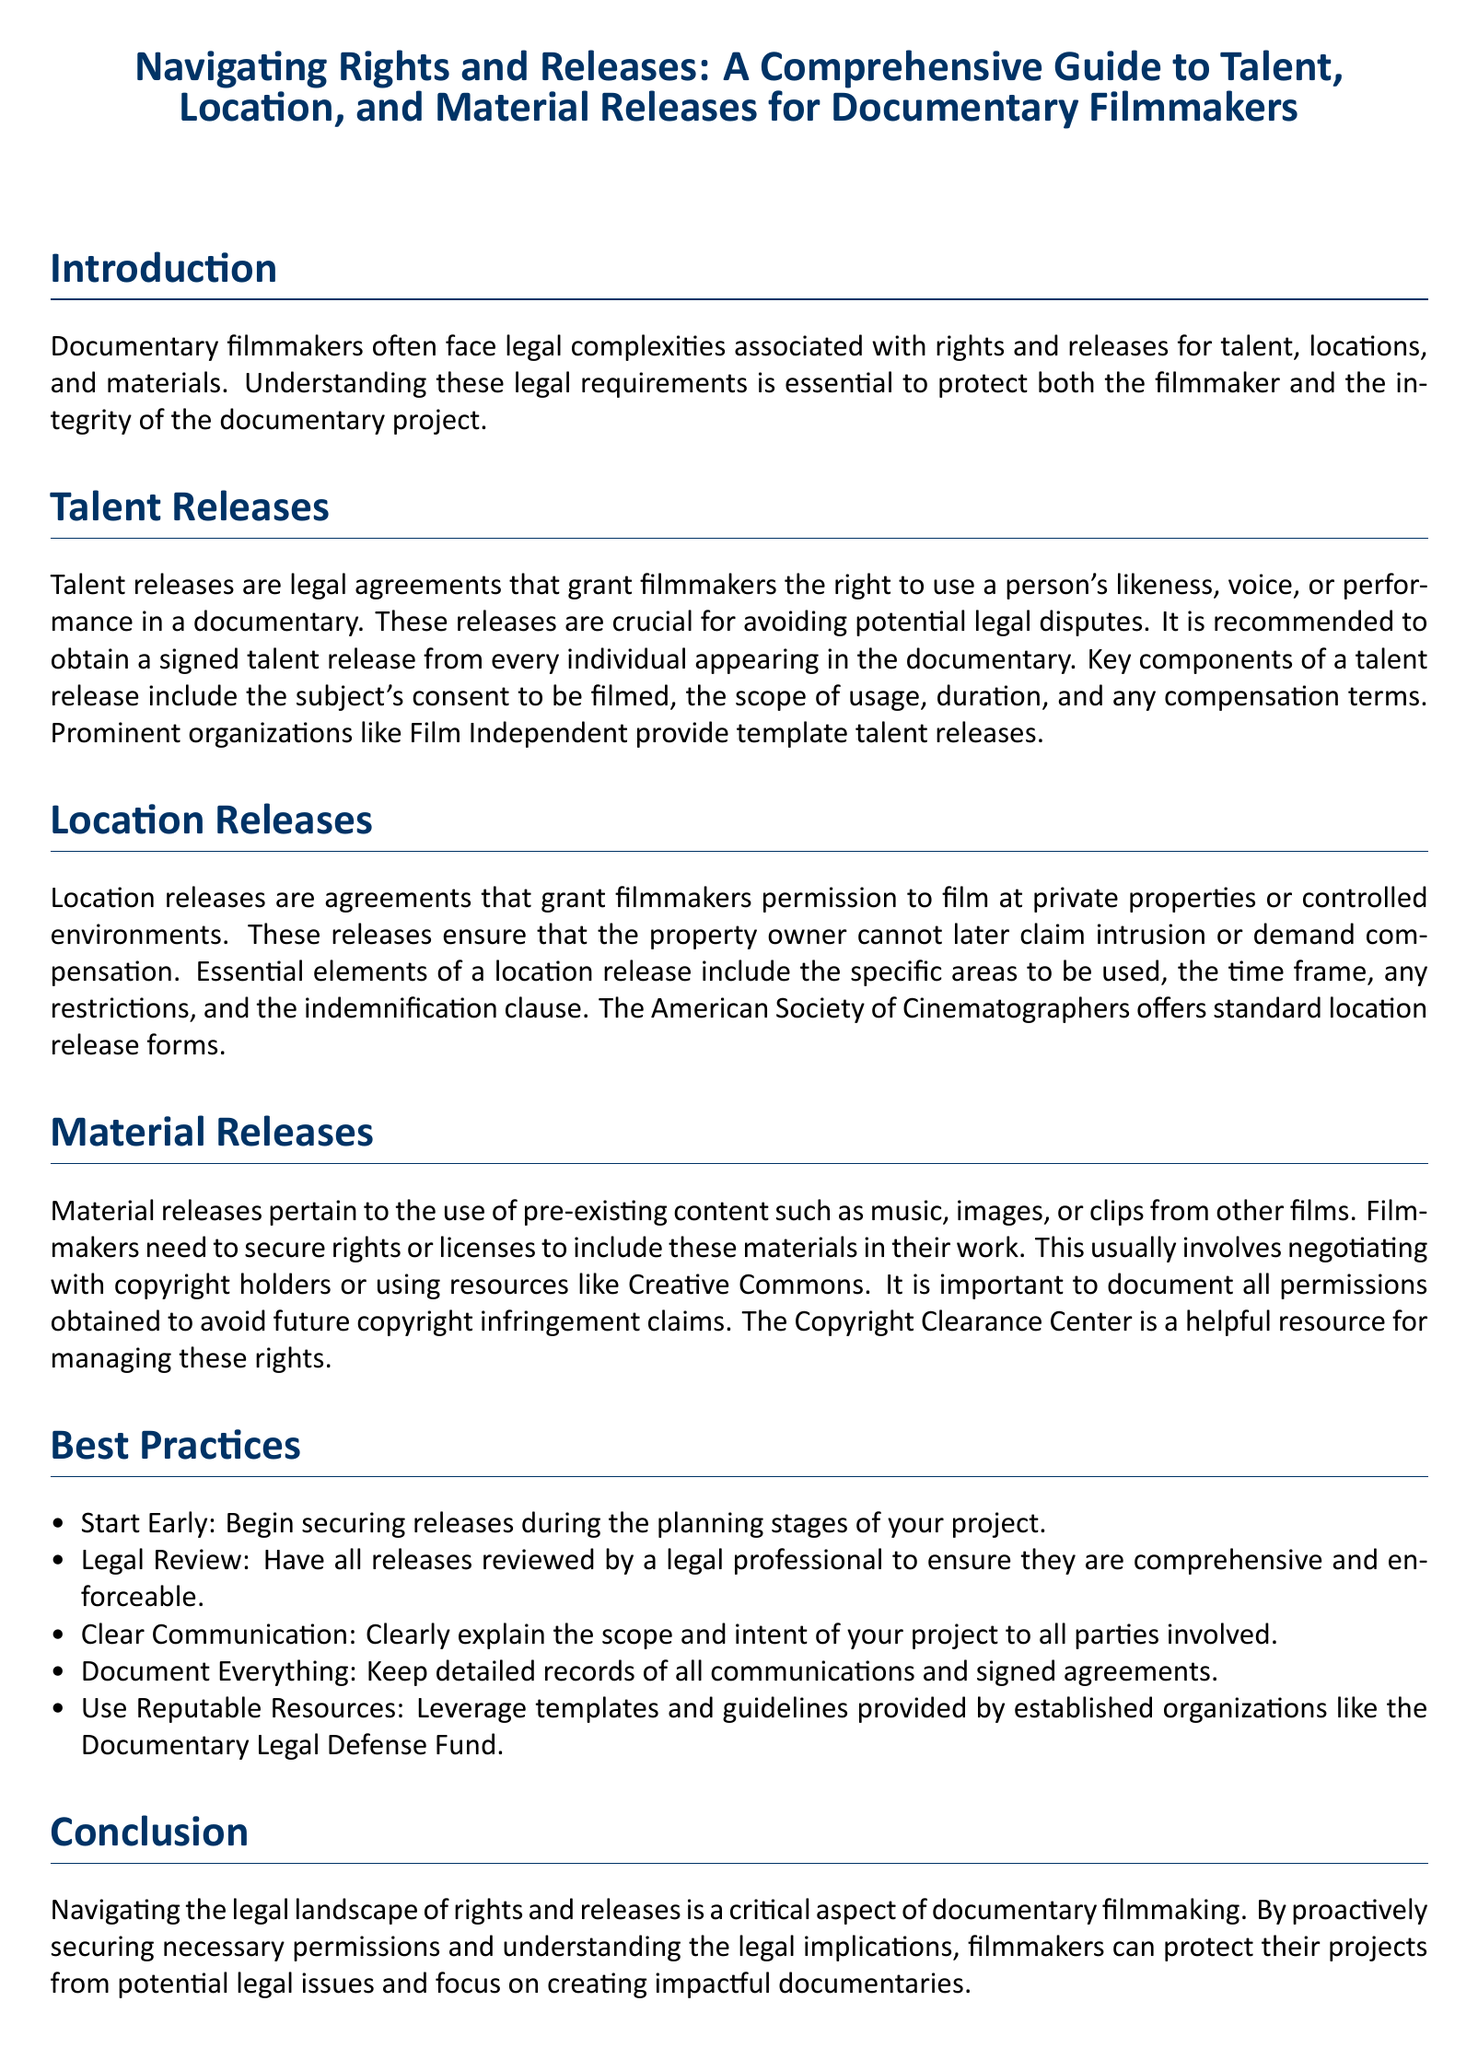What are talent releases? Talent releases are legal agreements that grant filmmakers the right to use a person's likeness, voice, or performance in a documentary.
Answer: Legal agreements What does a talent release include? Key components of a talent release include the subject's consent to be filmed, the scope of usage, duration, and any compensation terms.
Answer: Consent, scope, duration, compensation Which organization provides template talent releases? Prominent organizations like Film Independent provide template talent releases.
Answer: Film Independent What is an essential element of a location release? Essential elements of a location release include the specific areas to be used, the time frame, any restrictions, and the indemnification clause.
Answer: Specific areas, time frame, restrictions, indemnification What should filmmakers do with pre-existing content? Filmmakers need to secure rights or licenses to include these materials in their work.
Answer: Secure rights or licenses What is a recommended best practice for securing releases? Start Early: Begin securing releases during the planning stages of your project.
Answer: Start Early Which resource can help manage copyright rights? The Copyright Clearance Center is a helpful resource for managing these rights.
Answer: Copyright Clearance Center What is a critical aspect of documentary filmmaking? Navigating the legal landscape of rights and releases is a critical aspect of documentary filmmaking.
Answer: Legal landscape Who offers standard location release forms? The American Society of Cinematographers offers standard location release forms.
Answer: American Society of Cinematographers 